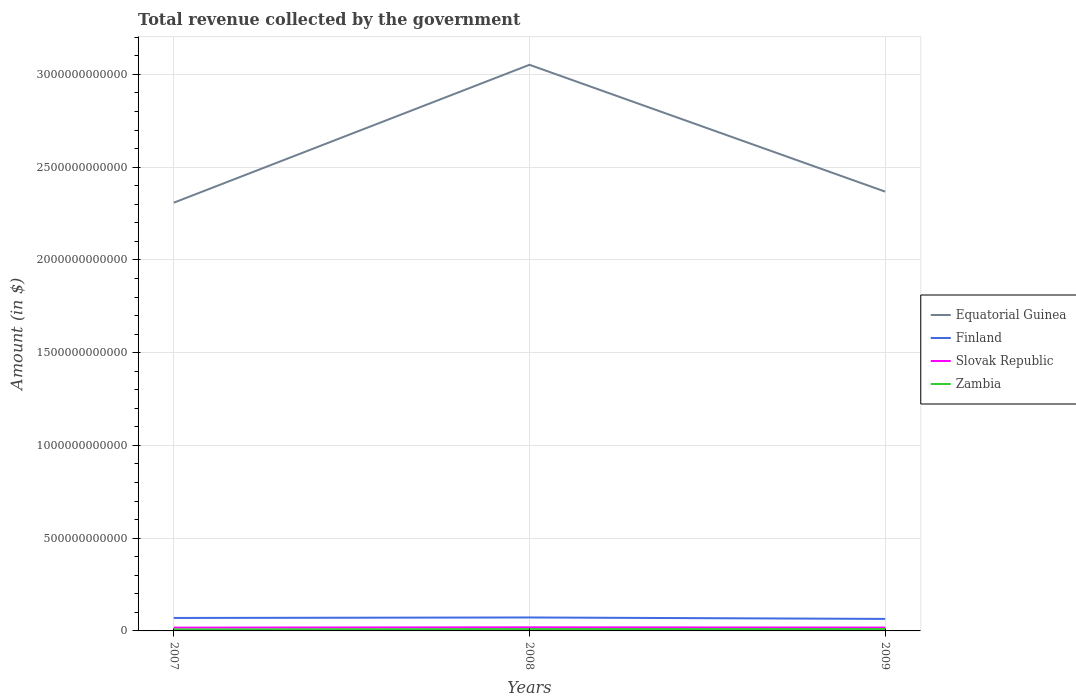Does the line corresponding to Equatorial Guinea intersect with the line corresponding to Finland?
Your answer should be very brief. No. Across all years, what is the maximum total revenue collected by the government in Zambia?
Your answer should be compact. 8.04e+09. In which year was the total revenue collected by the government in Finland maximum?
Provide a succinct answer. 2009. What is the total total revenue collected by the government in Zambia in the graph?
Ensure brevity in your answer.  -2.06e+09. What is the difference between the highest and the second highest total revenue collected by the government in Slovak Republic?
Your answer should be compact. 1.69e+09. Is the total revenue collected by the government in Slovak Republic strictly greater than the total revenue collected by the government in Finland over the years?
Offer a very short reply. Yes. What is the difference between two consecutive major ticks on the Y-axis?
Provide a succinct answer. 5.00e+11. Does the graph contain any zero values?
Give a very brief answer. No. Where does the legend appear in the graph?
Provide a succinct answer. Center right. How are the legend labels stacked?
Ensure brevity in your answer.  Vertical. What is the title of the graph?
Your answer should be compact. Total revenue collected by the government. Does "St. Vincent and the Grenadines" appear as one of the legend labels in the graph?
Make the answer very short. No. What is the label or title of the Y-axis?
Keep it short and to the point. Amount (in $). What is the Amount (in $) in Equatorial Guinea in 2007?
Your answer should be compact. 2.31e+12. What is the Amount (in $) of Finland in 2007?
Offer a terse response. 6.99e+1. What is the Amount (in $) in Slovak Republic in 2007?
Keep it short and to the point. 1.78e+1. What is the Amount (in $) of Zambia in 2007?
Offer a terse response. 8.04e+09. What is the Amount (in $) of Equatorial Guinea in 2008?
Provide a succinct answer. 3.05e+12. What is the Amount (in $) of Finland in 2008?
Your answer should be very brief. 7.26e+1. What is the Amount (in $) in Slovak Republic in 2008?
Ensure brevity in your answer.  1.95e+1. What is the Amount (in $) in Zambia in 2008?
Provide a short and direct response. 1.01e+1. What is the Amount (in $) in Equatorial Guinea in 2009?
Offer a very short reply. 2.37e+12. What is the Amount (in $) of Finland in 2009?
Ensure brevity in your answer.  6.47e+1. What is the Amount (in $) in Slovak Republic in 2009?
Keep it short and to the point. 1.80e+1. What is the Amount (in $) of Zambia in 2009?
Make the answer very short. 1.01e+1. Across all years, what is the maximum Amount (in $) in Equatorial Guinea?
Offer a terse response. 3.05e+12. Across all years, what is the maximum Amount (in $) of Finland?
Your answer should be very brief. 7.26e+1. Across all years, what is the maximum Amount (in $) of Slovak Republic?
Offer a very short reply. 1.95e+1. Across all years, what is the maximum Amount (in $) of Zambia?
Make the answer very short. 1.01e+1. Across all years, what is the minimum Amount (in $) in Equatorial Guinea?
Your answer should be compact. 2.31e+12. Across all years, what is the minimum Amount (in $) in Finland?
Give a very brief answer. 6.47e+1. Across all years, what is the minimum Amount (in $) in Slovak Republic?
Your response must be concise. 1.78e+1. Across all years, what is the minimum Amount (in $) of Zambia?
Keep it short and to the point. 8.04e+09. What is the total Amount (in $) of Equatorial Guinea in the graph?
Give a very brief answer. 7.73e+12. What is the total Amount (in $) of Finland in the graph?
Keep it short and to the point. 2.07e+11. What is the total Amount (in $) of Slovak Republic in the graph?
Ensure brevity in your answer.  5.53e+1. What is the total Amount (in $) of Zambia in the graph?
Offer a very short reply. 2.82e+1. What is the difference between the Amount (in $) in Equatorial Guinea in 2007 and that in 2008?
Offer a terse response. -7.43e+11. What is the difference between the Amount (in $) in Finland in 2007 and that in 2008?
Your answer should be very brief. -2.66e+09. What is the difference between the Amount (in $) of Slovak Republic in 2007 and that in 2008?
Keep it short and to the point. -1.69e+09. What is the difference between the Amount (in $) in Zambia in 2007 and that in 2008?
Make the answer very short. -2.04e+09. What is the difference between the Amount (in $) of Equatorial Guinea in 2007 and that in 2009?
Provide a short and direct response. -5.96e+1. What is the difference between the Amount (in $) of Finland in 2007 and that in 2009?
Your response must be concise. 5.15e+09. What is the difference between the Amount (in $) of Slovak Republic in 2007 and that in 2009?
Keep it short and to the point. -2.09e+08. What is the difference between the Amount (in $) of Zambia in 2007 and that in 2009?
Keep it short and to the point. -2.06e+09. What is the difference between the Amount (in $) of Equatorial Guinea in 2008 and that in 2009?
Provide a succinct answer. 6.84e+11. What is the difference between the Amount (in $) in Finland in 2008 and that in 2009?
Offer a terse response. 7.81e+09. What is the difference between the Amount (in $) of Slovak Republic in 2008 and that in 2009?
Your response must be concise. 1.48e+09. What is the difference between the Amount (in $) of Zambia in 2008 and that in 2009?
Give a very brief answer. -2.46e+07. What is the difference between the Amount (in $) of Equatorial Guinea in 2007 and the Amount (in $) of Finland in 2008?
Give a very brief answer. 2.24e+12. What is the difference between the Amount (in $) of Equatorial Guinea in 2007 and the Amount (in $) of Slovak Republic in 2008?
Your answer should be compact. 2.29e+12. What is the difference between the Amount (in $) in Equatorial Guinea in 2007 and the Amount (in $) in Zambia in 2008?
Provide a succinct answer. 2.30e+12. What is the difference between the Amount (in $) of Finland in 2007 and the Amount (in $) of Slovak Republic in 2008?
Your answer should be very brief. 5.04e+1. What is the difference between the Amount (in $) in Finland in 2007 and the Amount (in $) in Zambia in 2008?
Provide a succinct answer. 5.98e+1. What is the difference between the Amount (in $) in Slovak Republic in 2007 and the Amount (in $) in Zambia in 2008?
Your answer should be compact. 7.71e+09. What is the difference between the Amount (in $) of Equatorial Guinea in 2007 and the Amount (in $) of Finland in 2009?
Provide a short and direct response. 2.24e+12. What is the difference between the Amount (in $) of Equatorial Guinea in 2007 and the Amount (in $) of Slovak Republic in 2009?
Your answer should be very brief. 2.29e+12. What is the difference between the Amount (in $) in Equatorial Guinea in 2007 and the Amount (in $) in Zambia in 2009?
Make the answer very short. 2.30e+12. What is the difference between the Amount (in $) in Finland in 2007 and the Amount (in $) in Slovak Republic in 2009?
Provide a short and direct response. 5.19e+1. What is the difference between the Amount (in $) in Finland in 2007 and the Amount (in $) in Zambia in 2009?
Provide a succinct answer. 5.98e+1. What is the difference between the Amount (in $) in Slovak Republic in 2007 and the Amount (in $) in Zambia in 2009?
Provide a succinct answer. 7.69e+09. What is the difference between the Amount (in $) of Equatorial Guinea in 2008 and the Amount (in $) of Finland in 2009?
Ensure brevity in your answer.  2.99e+12. What is the difference between the Amount (in $) of Equatorial Guinea in 2008 and the Amount (in $) of Slovak Republic in 2009?
Your response must be concise. 3.03e+12. What is the difference between the Amount (in $) in Equatorial Guinea in 2008 and the Amount (in $) in Zambia in 2009?
Ensure brevity in your answer.  3.04e+12. What is the difference between the Amount (in $) in Finland in 2008 and the Amount (in $) in Slovak Republic in 2009?
Offer a terse response. 5.46e+1. What is the difference between the Amount (in $) in Finland in 2008 and the Amount (in $) in Zambia in 2009?
Your answer should be compact. 6.25e+1. What is the difference between the Amount (in $) of Slovak Republic in 2008 and the Amount (in $) of Zambia in 2009?
Give a very brief answer. 9.37e+09. What is the average Amount (in $) of Equatorial Guinea per year?
Your response must be concise. 2.58e+12. What is the average Amount (in $) in Finland per year?
Ensure brevity in your answer.  6.91e+1. What is the average Amount (in $) in Slovak Republic per year?
Offer a very short reply. 1.84e+1. What is the average Amount (in $) in Zambia per year?
Your answer should be very brief. 9.40e+09. In the year 2007, what is the difference between the Amount (in $) in Equatorial Guinea and Amount (in $) in Finland?
Ensure brevity in your answer.  2.24e+12. In the year 2007, what is the difference between the Amount (in $) of Equatorial Guinea and Amount (in $) of Slovak Republic?
Make the answer very short. 2.29e+12. In the year 2007, what is the difference between the Amount (in $) of Equatorial Guinea and Amount (in $) of Zambia?
Ensure brevity in your answer.  2.30e+12. In the year 2007, what is the difference between the Amount (in $) in Finland and Amount (in $) in Slovak Republic?
Provide a short and direct response. 5.21e+1. In the year 2007, what is the difference between the Amount (in $) in Finland and Amount (in $) in Zambia?
Keep it short and to the point. 6.19e+1. In the year 2007, what is the difference between the Amount (in $) in Slovak Republic and Amount (in $) in Zambia?
Provide a succinct answer. 9.75e+09. In the year 2008, what is the difference between the Amount (in $) of Equatorial Guinea and Amount (in $) of Finland?
Make the answer very short. 2.98e+12. In the year 2008, what is the difference between the Amount (in $) of Equatorial Guinea and Amount (in $) of Slovak Republic?
Provide a succinct answer. 3.03e+12. In the year 2008, what is the difference between the Amount (in $) of Equatorial Guinea and Amount (in $) of Zambia?
Your answer should be very brief. 3.04e+12. In the year 2008, what is the difference between the Amount (in $) in Finland and Amount (in $) in Slovak Republic?
Your answer should be compact. 5.31e+1. In the year 2008, what is the difference between the Amount (in $) of Finland and Amount (in $) of Zambia?
Keep it short and to the point. 6.25e+1. In the year 2008, what is the difference between the Amount (in $) of Slovak Republic and Amount (in $) of Zambia?
Make the answer very short. 9.40e+09. In the year 2009, what is the difference between the Amount (in $) in Equatorial Guinea and Amount (in $) in Finland?
Give a very brief answer. 2.30e+12. In the year 2009, what is the difference between the Amount (in $) of Equatorial Guinea and Amount (in $) of Slovak Republic?
Provide a short and direct response. 2.35e+12. In the year 2009, what is the difference between the Amount (in $) in Equatorial Guinea and Amount (in $) in Zambia?
Ensure brevity in your answer.  2.36e+12. In the year 2009, what is the difference between the Amount (in $) of Finland and Amount (in $) of Slovak Republic?
Provide a short and direct response. 4.67e+1. In the year 2009, what is the difference between the Amount (in $) in Finland and Amount (in $) in Zambia?
Provide a short and direct response. 5.46e+1. In the year 2009, what is the difference between the Amount (in $) in Slovak Republic and Amount (in $) in Zambia?
Your answer should be compact. 7.90e+09. What is the ratio of the Amount (in $) of Equatorial Guinea in 2007 to that in 2008?
Provide a succinct answer. 0.76. What is the ratio of the Amount (in $) of Finland in 2007 to that in 2008?
Keep it short and to the point. 0.96. What is the ratio of the Amount (in $) in Slovak Republic in 2007 to that in 2008?
Give a very brief answer. 0.91. What is the ratio of the Amount (in $) in Zambia in 2007 to that in 2008?
Keep it short and to the point. 0.8. What is the ratio of the Amount (in $) of Equatorial Guinea in 2007 to that in 2009?
Provide a succinct answer. 0.97. What is the ratio of the Amount (in $) in Finland in 2007 to that in 2009?
Offer a terse response. 1.08. What is the ratio of the Amount (in $) of Slovak Republic in 2007 to that in 2009?
Provide a succinct answer. 0.99. What is the ratio of the Amount (in $) in Zambia in 2007 to that in 2009?
Provide a succinct answer. 0.8. What is the ratio of the Amount (in $) of Equatorial Guinea in 2008 to that in 2009?
Give a very brief answer. 1.29. What is the ratio of the Amount (in $) of Finland in 2008 to that in 2009?
Offer a very short reply. 1.12. What is the ratio of the Amount (in $) in Slovak Republic in 2008 to that in 2009?
Give a very brief answer. 1.08. What is the difference between the highest and the second highest Amount (in $) in Equatorial Guinea?
Your answer should be compact. 6.84e+11. What is the difference between the highest and the second highest Amount (in $) in Finland?
Make the answer very short. 2.66e+09. What is the difference between the highest and the second highest Amount (in $) in Slovak Republic?
Provide a succinct answer. 1.48e+09. What is the difference between the highest and the second highest Amount (in $) of Zambia?
Offer a very short reply. 2.46e+07. What is the difference between the highest and the lowest Amount (in $) of Equatorial Guinea?
Offer a very short reply. 7.43e+11. What is the difference between the highest and the lowest Amount (in $) in Finland?
Offer a very short reply. 7.81e+09. What is the difference between the highest and the lowest Amount (in $) in Slovak Republic?
Your answer should be compact. 1.69e+09. What is the difference between the highest and the lowest Amount (in $) of Zambia?
Your response must be concise. 2.06e+09. 